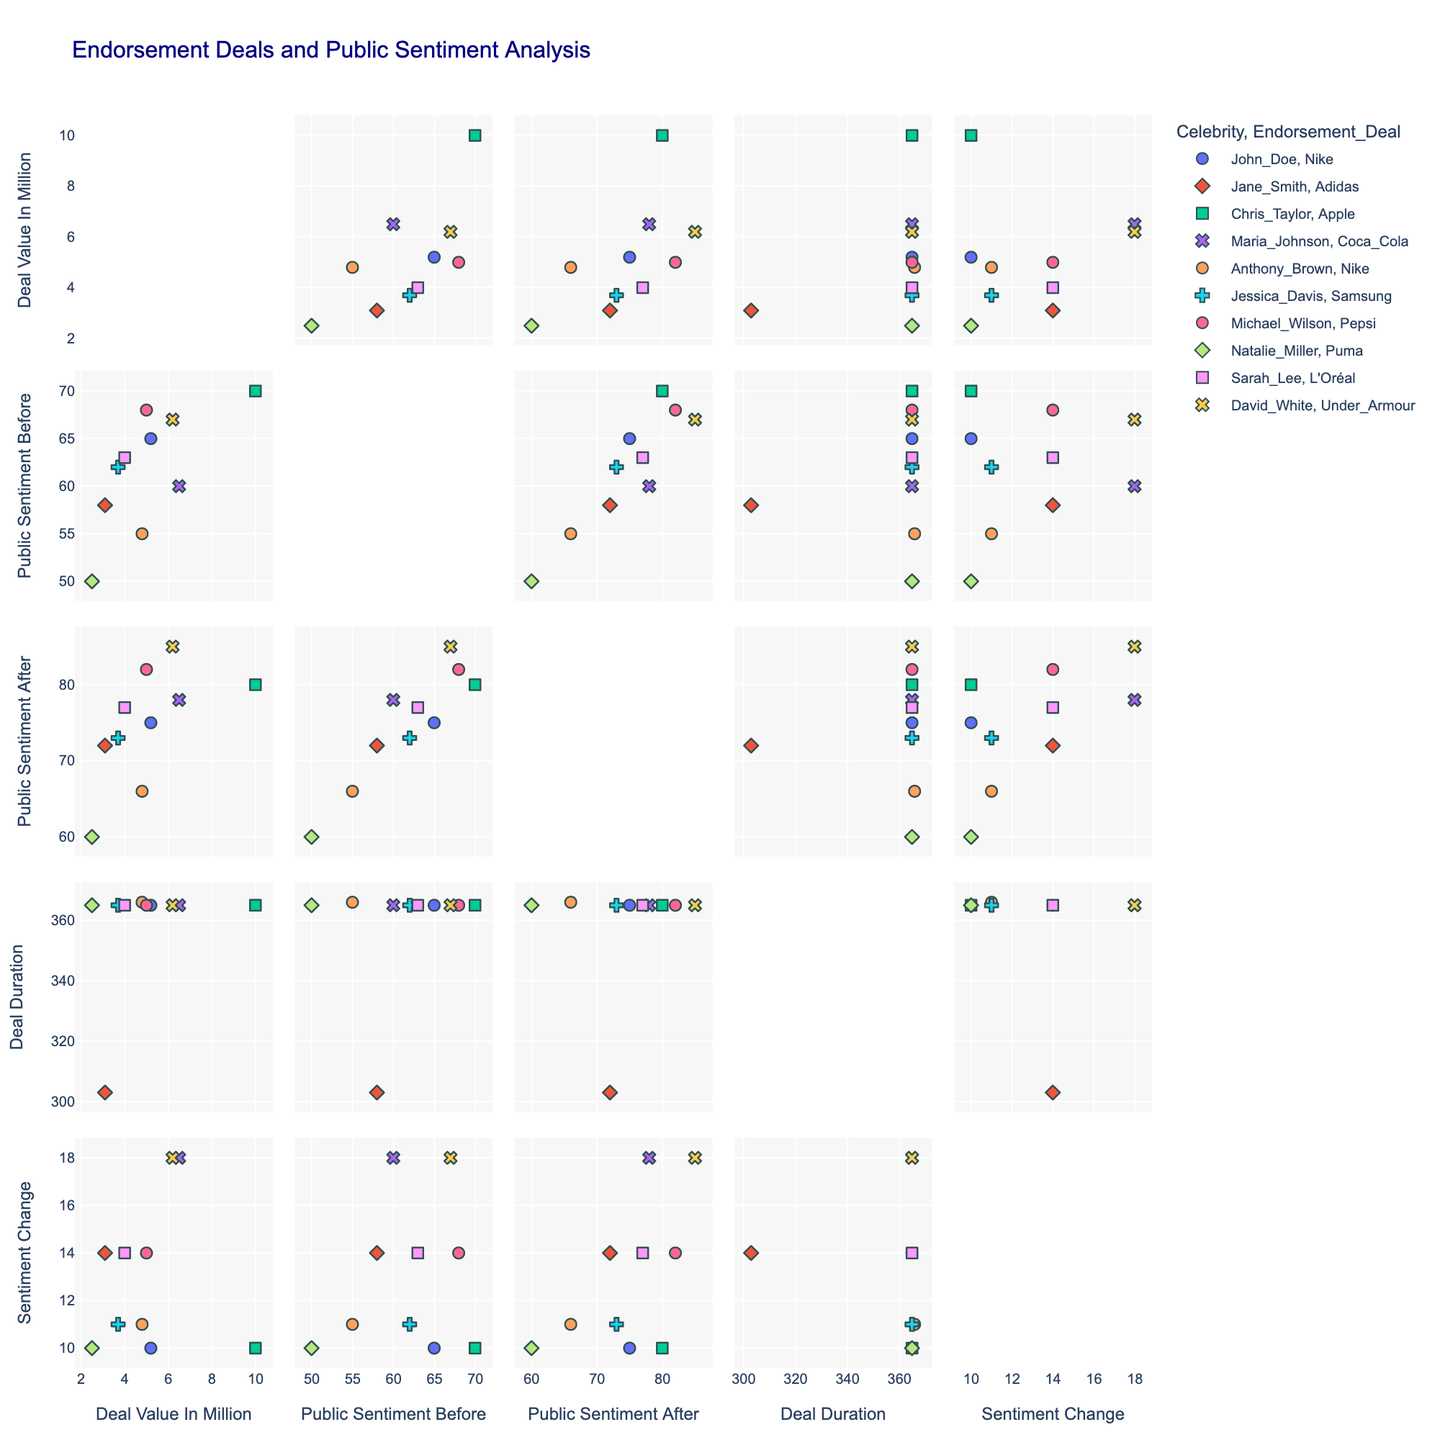What's the title of the figure? The title is located at the top of the figure. It's visually prominent and set in navy color in larger font size.
Answer: Endorsement Deals and Public Sentiment Analysis What does the color of the data points represent? Each color in the scatter plot matrix represents a different celebrity. This can be identified by checking the legend, which maps colors to celebrity names.
Answer: Celebrity Which endorsement deal has the highest 'Public Sentiment After'? Identify the highest value of 'Public Sentiment After' on the y-axis of the scatter plots and check the corresponding symbols for endorsement deals.
Answer: Pepsi (Michael_Wilson) Which celebrity has the longest endorsement deal duration? Look at the scatter plots that include 'Deal Duration' to find the highest value. Then check the color and the legend for the corresponding celebrity.
Answer: Dave_White What is the median deal value of all plots? 'Deal_Value_In_Million' can be median-calculated by listing all deal values, sorting them, and finding the middle value. The deal values are: [2.5, 3.1, 3.7, 4.0, 4.8, 5.0, 5.2, 6.2, 6.5, 10.0]. The median of these ten numbers lies between the 5th and 6th values after sorting, which are 4.8 and 5.0, so the median deal value is 4.9 million dollars.
Answer: 4.9 Which endorsement deal has the greatest change in sentiment post-deal compared to pre-deal? Look for the highest 'Sentiment_Change' value on the y-axis. Cross-reference this with the corresponding endorsement deal symbol and verify with hover data.
Answer: Under_Armour (David_White) Compare 'Public Sentiment Before' and 'Public Sentiment After' for the celebrity with the highest end-of-deal sentiment. What is the difference? First, find the celebrity with the highest 'Public Sentiment After' (Michael_Wilson, Pepsi). Then, subtract 'Public_Sentiment_Before' (68) from 'Public_Sentiment_After' (82).
Answer: 14 In the scatter plot with 'Deal Value In Million' and 'Sentiment Change', which celebrity has the highest deal value and what is their sentiment change? Identify the point with the highest 'Deal Value In Million' on the x-axis and cross-check the color for the celebrity. Their sentiment change can be read off of the y-axis.
Answer: Chris_Taylor (10.0, 10) Which deal has the shortest duration in the scatter plot matrix? In the plots containing 'Deal Duration', look for the shortest value along the axis. Verify the corresponding deal by cross-referencing symbols or hover data.
Answer: Puma (Natalie_Miller), 365 days Looking at the scatter plot with 'Deal Value In Million' and 'Public Sentiment Before', which two endorsement deals are most closely clustered? Identify the points that are closest to each other on the scatter plot with 'Deal Value In Million' on the x-axis and 'Public Sentiment Before' on the y-axis.
Answer: Samsung (Jessica_Davis) and Coca Cola (Maria_Johnson) 